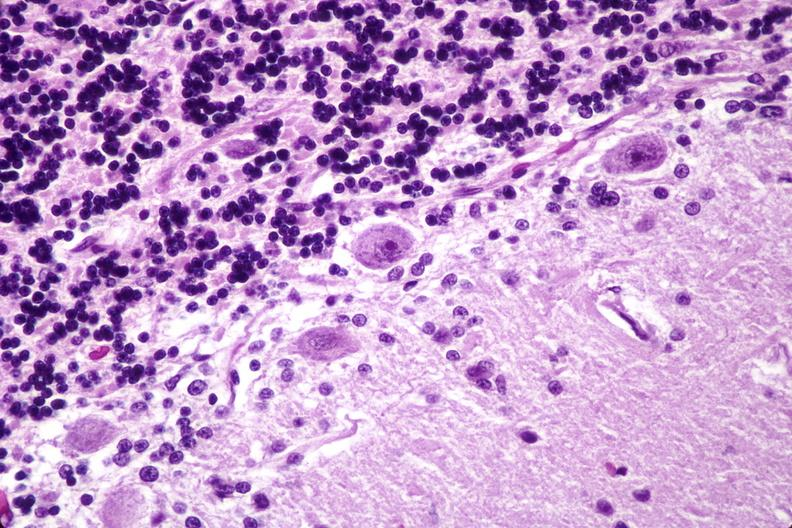what does this image show?
Answer the question using a single word or phrase. Brain lymphoma 